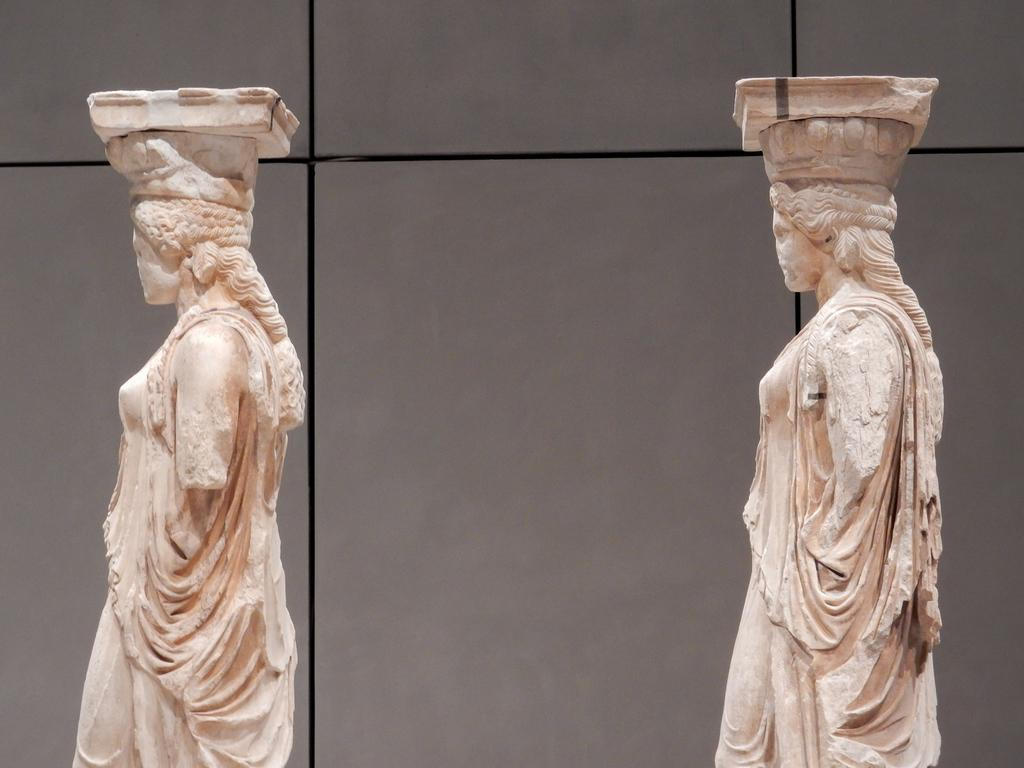What can be seen in the image? There are two sculptures in the image. How are the sculptures positioned? The sculptures are standing. What is visible in the background of the image? There is a wall in the background of the image. What type of skirt is the doll wearing in the image? There is no doll present in the image, so it is not possible to determine what type of skirt the doll might be wearing. 